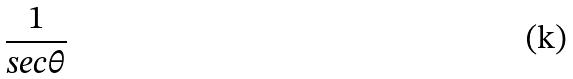<formula> <loc_0><loc_0><loc_500><loc_500>\frac { 1 } { s e c \theta }</formula> 